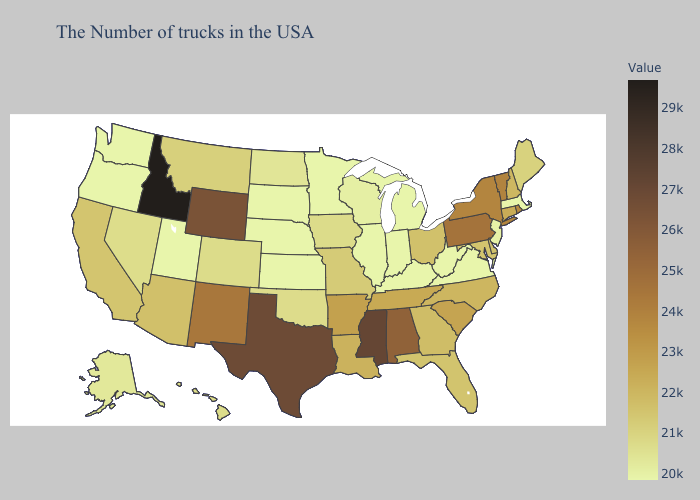Does Wyoming have the lowest value in the USA?
Write a very short answer. No. Which states hav the highest value in the MidWest?
Answer briefly. Ohio. Which states have the highest value in the USA?
Answer briefly. Idaho. Which states hav the highest value in the MidWest?
Give a very brief answer. Ohio. Among the states that border South Dakota , which have the lowest value?
Answer briefly. Minnesota, Nebraska. 